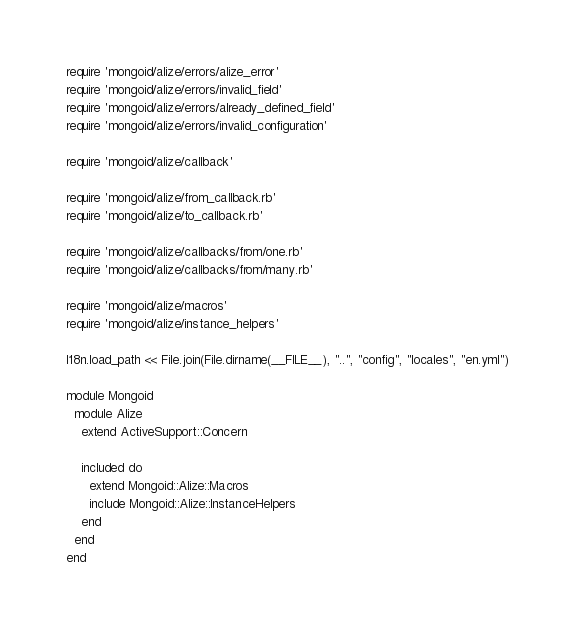<code> <loc_0><loc_0><loc_500><loc_500><_Ruby_>require 'mongoid/alize/errors/alize_error'
require 'mongoid/alize/errors/invalid_field'
require 'mongoid/alize/errors/already_defined_field'
require 'mongoid/alize/errors/invalid_configuration'

require 'mongoid/alize/callback'

require 'mongoid/alize/from_callback.rb'
require 'mongoid/alize/to_callback.rb'

require 'mongoid/alize/callbacks/from/one.rb'
require 'mongoid/alize/callbacks/from/many.rb'

require 'mongoid/alize/macros'
require 'mongoid/alize/instance_helpers'

I18n.load_path << File.join(File.dirname(__FILE__), "..", "config", "locales", "en.yml")

module Mongoid
  module Alize
    extend ActiveSupport::Concern

    included do
      extend Mongoid::Alize::Macros
      include Mongoid::Alize::InstanceHelpers
    end
  end
end
</code> 